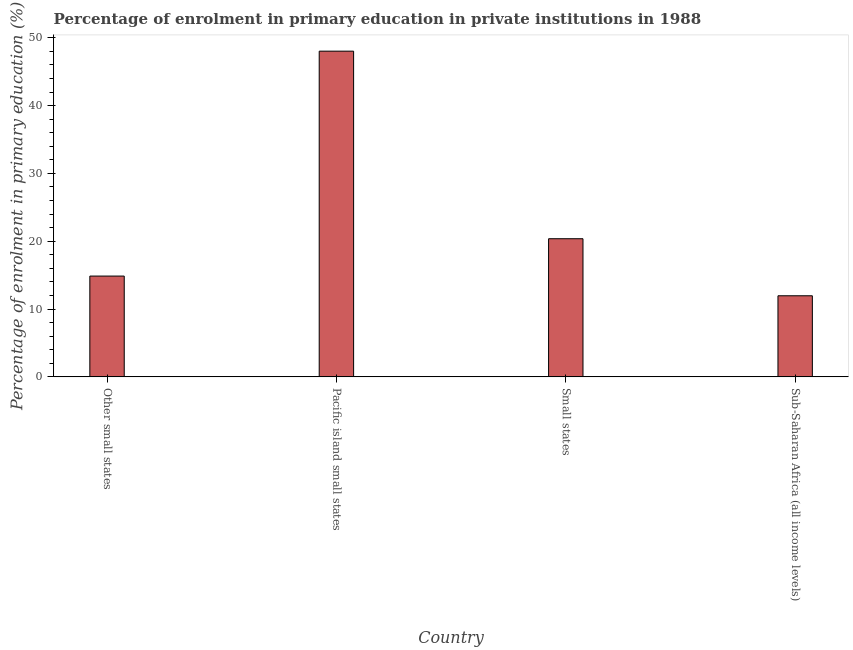Does the graph contain any zero values?
Offer a very short reply. No. What is the title of the graph?
Your answer should be very brief. Percentage of enrolment in primary education in private institutions in 1988. What is the label or title of the Y-axis?
Keep it short and to the point. Percentage of enrolment in primary education (%). What is the enrolment percentage in primary education in Small states?
Offer a terse response. 20.37. Across all countries, what is the maximum enrolment percentage in primary education?
Ensure brevity in your answer.  48.03. Across all countries, what is the minimum enrolment percentage in primary education?
Give a very brief answer. 11.96. In which country was the enrolment percentage in primary education maximum?
Your answer should be very brief. Pacific island small states. In which country was the enrolment percentage in primary education minimum?
Your response must be concise. Sub-Saharan Africa (all income levels). What is the sum of the enrolment percentage in primary education?
Your response must be concise. 95.23. What is the difference between the enrolment percentage in primary education in Other small states and Sub-Saharan Africa (all income levels)?
Your answer should be very brief. 2.91. What is the average enrolment percentage in primary education per country?
Your answer should be compact. 23.81. What is the median enrolment percentage in primary education?
Offer a very short reply. 17.62. What is the ratio of the enrolment percentage in primary education in Pacific island small states to that in Sub-Saharan Africa (all income levels)?
Your answer should be very brief. 4.02. Is the enrolment percentage in primary education in Pacific island small states less than that in Sub-Saharan Africa (all income levels)?
Your response must be concise. No. What is the difference between the highest and the second highest enrolment percentage in primary education?
Your answer should be very brief. 27.66. What is the difference between the highest and the lowest enrolment percentage in primary education?
Make the answer very short. 36.07. Are all the bars in the graph horizontal?
Keep it short and to the point. No. What is the difference between two consecutive major ticks on the Y-axis?
Keep it short and to the point. 10. Are the values on the major ticks of Y-axis written in scientific E-notation?
Your response must be concise. No. What is the Percentage of enrolment in primary education (%) in Other small states?
Ensure brevity in your answer.  14.86. What is the Percentage of enrolment in primary education (%) of Pacific island small states?
Offer a very short reply. 48.03. What is the Percentage of enrolment in primary education (%) of Small states?
Provide a succinct answer. 20.37. What is the Percentage of enrolment in primary education (%) of Sub-Saharan Africa (all income levels)?
Provide a succinct answer. 11.96. What is the difference between the Percentage of enrolment in primary education (%) in Other small states and Pacific island small states?
Give a very brief answer. -33.17. What is the difference between the Percentage of enrolment in primary education (%) in Other small states and Small states?
Provide a succinct answer. -5.51. What is the difference between the Percentage of enrolment in primary education (%) in Other small states and Sub-Saharan Africa (all income levels)?
Your answer should be compact. 2.91. What is the difference between the Percentage of enrolment in primary education (%) in Pacific island small states and Small states?
Offer a terse response. 27.66. What is the difference between the Percentage of enrolment in primary education (%) in Pacific island small states and Sub-Saharan Africa (all income levels)?
Give a very brief answer. 36.07. What is the difference between the Percentage of enrolment in primary education (%) in Small states and Sub-Saharan Africa (all income levels)?
Give a very brief answer. 8.41. What is the ratio of the Percentage of enrolment in primary education (%) in Other small states to that in Pacific island small states?
Offer a terse response. 0.31. What is the ratio of the Percentage of enrolment in primary education (%) in Other small states to that in Small states?
Give a very brief answer. 0.73. What is the ratio of the Percentage of enrolment in primary education (%) in Other small states to that in Sub-Saharan Africa (all income levels)?
Offer a terse response. 1.24. What is the ratio of the Percentage of enrolment in primary education (%) in Pacific island small states to that in Small states?
Your response must be concise. 2.36. What is the ratio of the Percentage of enrolment in primary education (%) in Pacific island small states to that in Sub-Saharan Africa (all income levels)?
Offer a very short reply. 4.02. What is the ratio of the Percentage of enrolment in primary education (%) in Small states to that in Sub-Saharan Africa (all income levels)?
Provide a short and direct response. 1.7. 